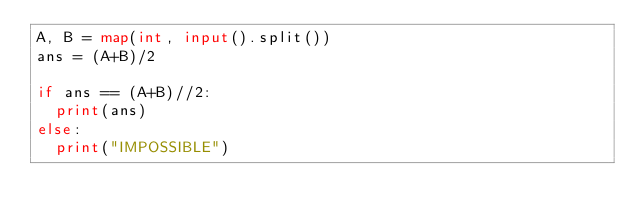<code> <loc_0><loc_0><loc_500><loc_500><_Python_>A, B = map(int, input().split())
ans = (A+B)/2

if ans == (A+B)//2:
  print(ans)
else:
  print("IMPOSSIBLE")</code> 